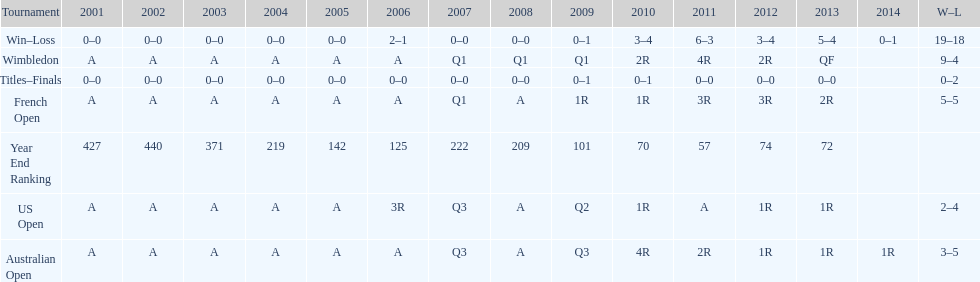Which tournament has the largest total win record? Wimbledon. 